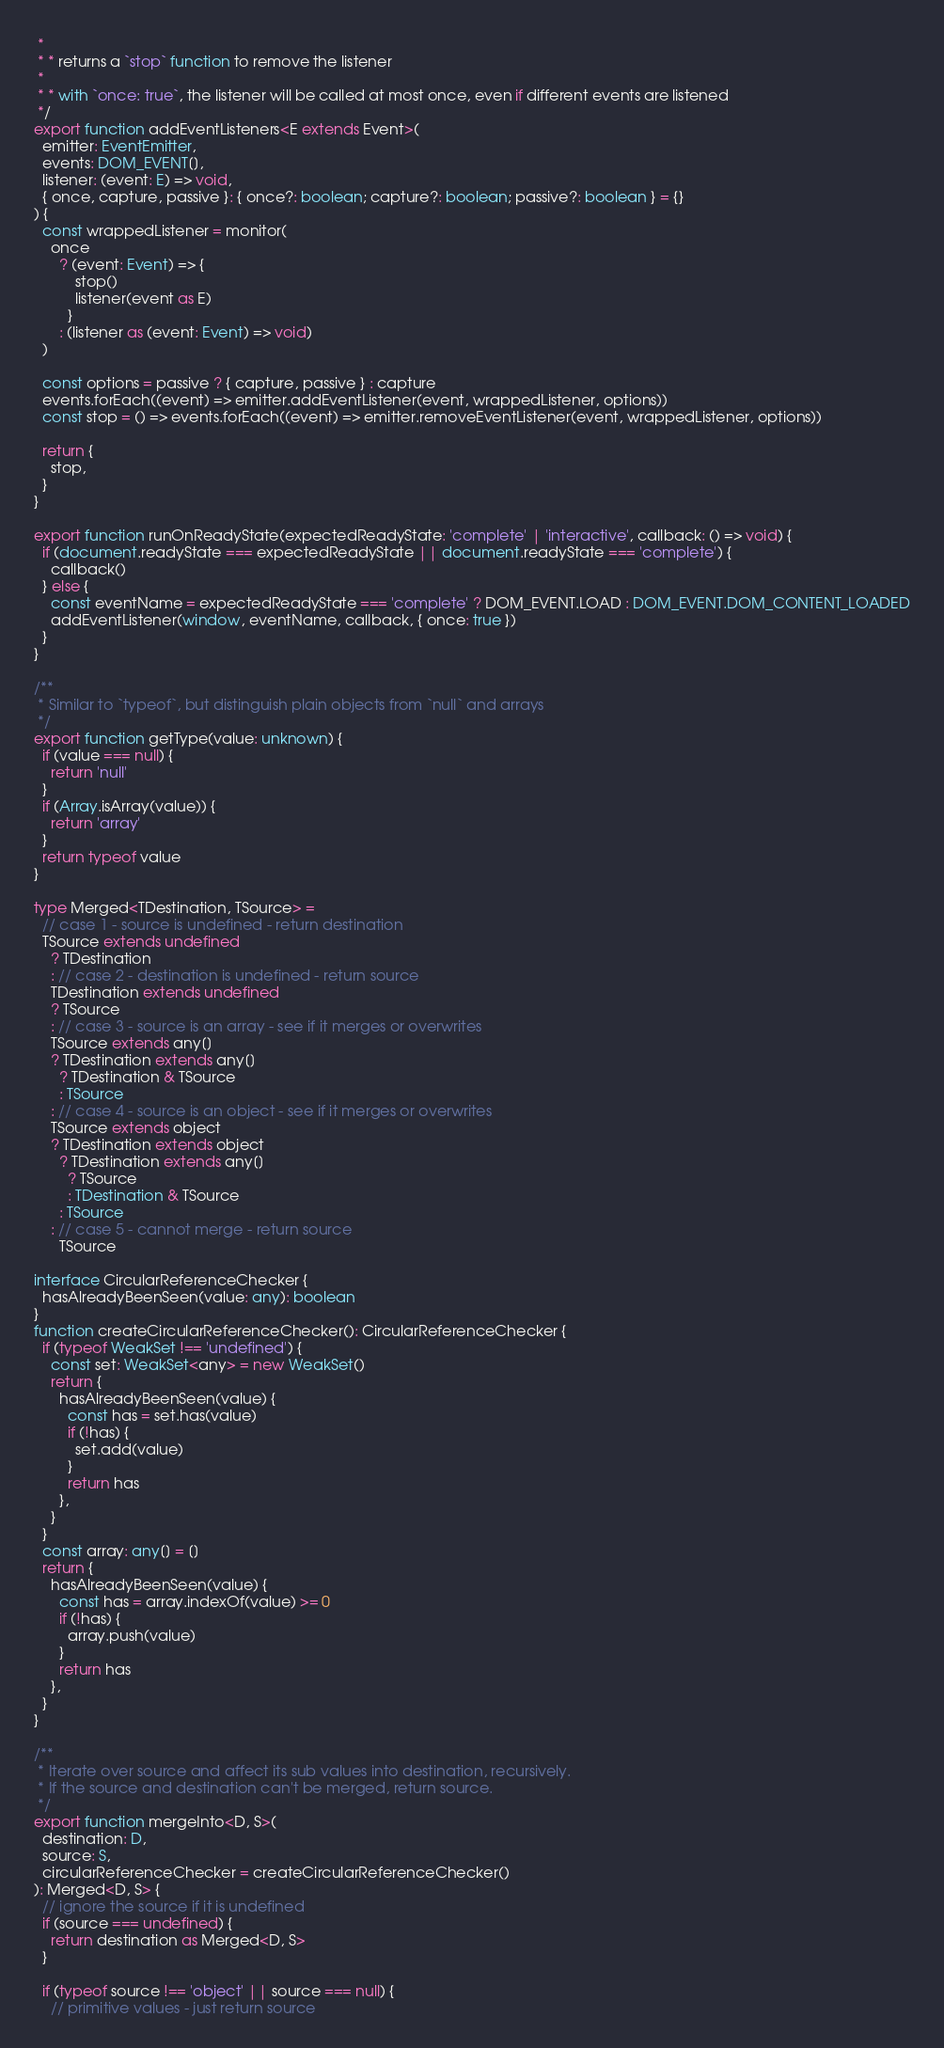<code> <loc_0><loc_0><loc_500><loc_500><_TypeScript_> *
 * * returns a `stop` function to remove the listener
 *
 * * with `once: true`, the listener will be called at most once, even if different events are listened
 */
export function addEventListeners<E extends Event>(
  emitter: EventEmitter,
  events: DOM_EVENT[],
  listener: (event: E) => void,
  { once, capture, passive }: { once?: boolean; capture?: boolean; passive?: boolean } = {}
) {
  const wrappedListener = monitor(
    once
      ? (event: Event) => {
          stop()
          listener(event as E)
        }
      : (listener as (event: Event) => void)
  )

  const options = passive ? { capture, passive } : capture
  events.forEach((event) => emitter.addEventListener(event, wrappedListener, options))
  const stop = () => events.forEach((event) => emitter.removeEventListener(event, wrappedListener, options))

  return {
    stop,
  }
}

export function runOnReadyState(expectedReadyState: 'complete' | 'interactive', callback: () => void) {
  if (document.readyState === expectedReadyState || document.readyState === 'complete') {
    callback()
  } else {
    const eventName = expectedReadyState === 'complete' ? DOM_EVENT.LOAD : DOM_EVENT.DOM_CONTENT_LOADED
    addEventListener(window, eventName, callback, { once: true })
  }
}

/**
 * Similar to `typeof`, but distinguish plain objects from `null` and arrays
 */
export function getType(value: unknown) {
  if (value === null) {
    return 'null'
  }
  if (Array.isArray(value)) {
    return 'array'
  }
  return typeof value
}

type Merged<TDestination, TSource> =
  // case 1 - source is undefined - return destination
  TSource extends undefined
    ? TDestination
    : // case 2 - destination is undefined - return source
    TDestination extends undefined
    ? TSource
    : // case 3 - source is an array - see if it merges or overwrites
    TSource extends any[]
    ? TDestination extends any[]
      ? TDestination & TSource
      : TSource
    : // case 4 - source is an object - see if it merges or overwrites
    TSource extends object
    ? TDestination extends object
      ? TDestination extends any[]
        ? TSource
        : TDestination & TSource
      : TSource
    : // case 5 - cannot merge - return source
      TSource

interface CircularReferenceChecker {
  hasAlreadyBeenSeen(value: any): boolean
}
function createCircularReferenceChecker(): CircularReferenceChecker {
  if (typeof WeakSet !== 'undefined') {
    const set: WeakSet<any> = new WeakSet()
    return {
      hasAlreadyBeenSeen(value) {
        const has = set.has(value)
        if (!has) {
          set.add(value)
        }
        return has
      },
    }
  }
  const array: any[] = []
  return {
    hasAlreadyBeenSeen(value) {
      const has = array.indexOf(value) >= 0
      if (!has) {
        array.push(value)
      }
      return has
    },
  }
}

/**
 * Iterate over source and affect its sub values into destination, recursively.
 * If the source and destination can't be merged, return source.
 */
export function mergeInto<D, S>(
  destination: D,
  source: S,
  circularReferenceChecker = createCircularReferenceChecker()
): Merged<D, S> {
  // ignore the source if it is undefined
  if (source === undefined) {
    return destination as Merged<D, S>
  }

  if (typeof source !== 'object' || source === null) {
    // primitive values - just return source</code> 